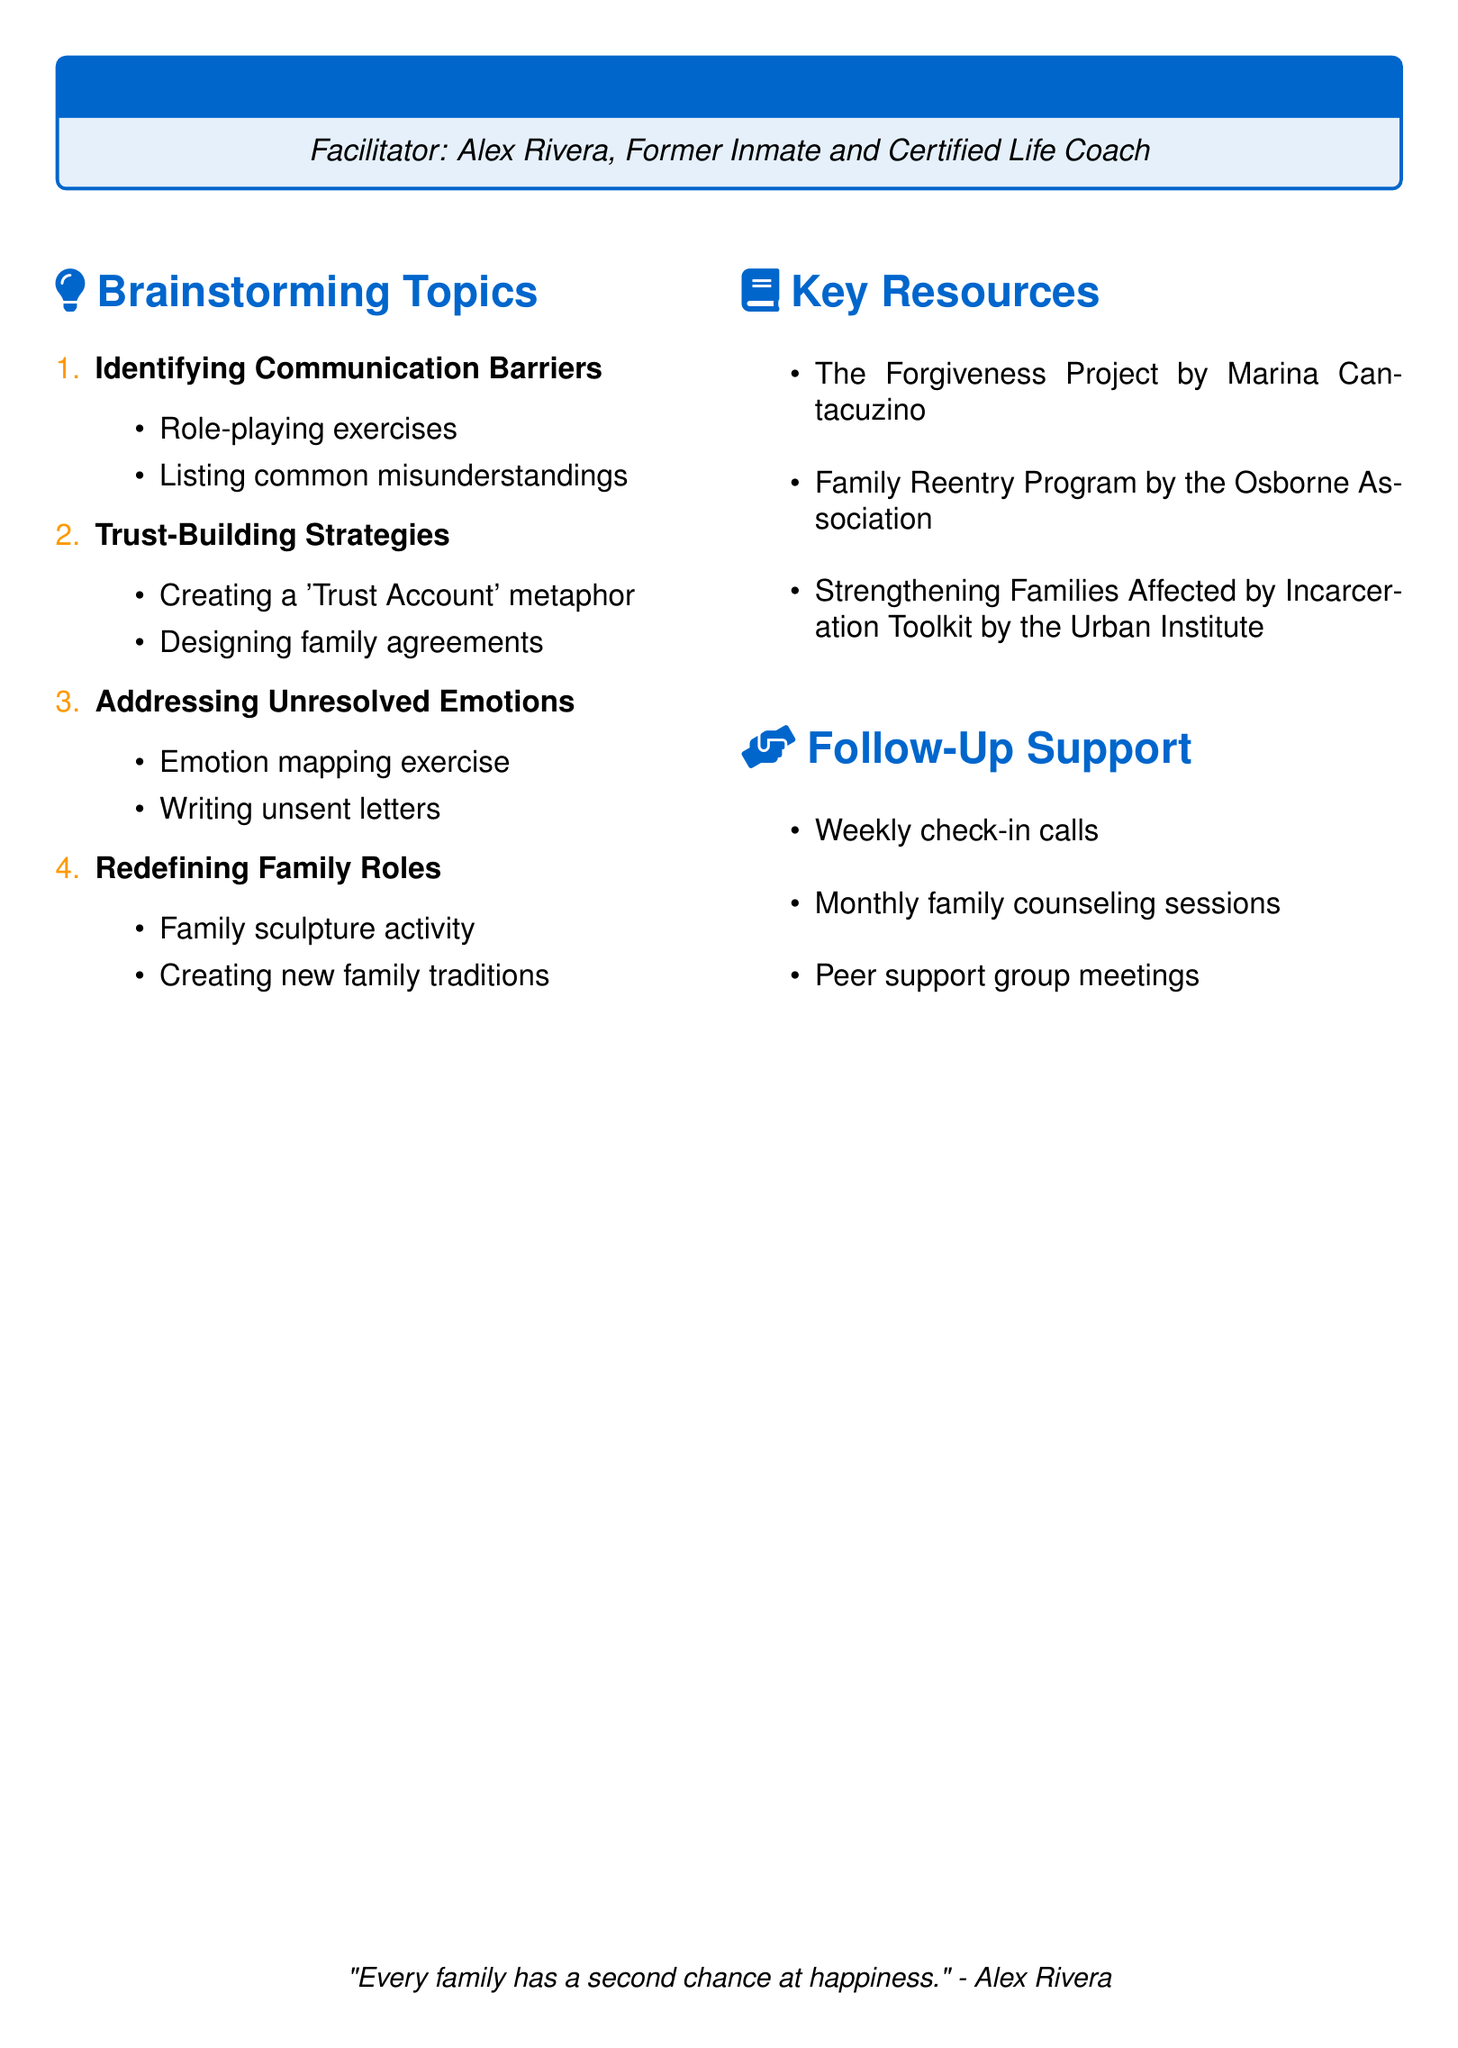What is the workshop title? The title is explicitly stated at the beginning of the document as "Rebuilding Family Bonds: Post-Incarceration Reconnection."
Answer: Rebuilding Family Bonds: Post-Incarceration Reconnection Who is the facilitator? The document lists the facilitator's name and background, stating that they are Alex Rivera, a former inmate and certified life coach.
Answer: Alex Rivera How many brainstorming topics are there? The number of brainstorming topics is counted from the list provided in the document, which contains four topics.
Answer: 4 What activity is part of the "Trust-Building Strategies" topic? The document lists activities under each topic, one of which is "Creating a 'Trust Account' metaphor" for the Trust-Building Strategies topic.
Answer: Creating a 'Trust Account' metaphor What resource is provided by the Osborne Association? The document specifies the resource "Family Reentry Program" is provided by the Osborne Association.
Answer: Family Reentry Program How often are the follow-up support check-in calls scheduled? The follow-up support section mentions "Weekly check-in calls," indicating the frequency of these calls.
Answer: Weekly What is one of the activities in "Addressing Unresolved Emotions"? An activity listed under this topic is "Writing unsent letters to family members."
Answer: Writing unsent letters to family members What does the concluding quote suggest? The quote at the end emphasizes the idea of second chances for families, conveying hope and positivity about rebuilding relationships.
Answer: Every family has a second chance at happiness 